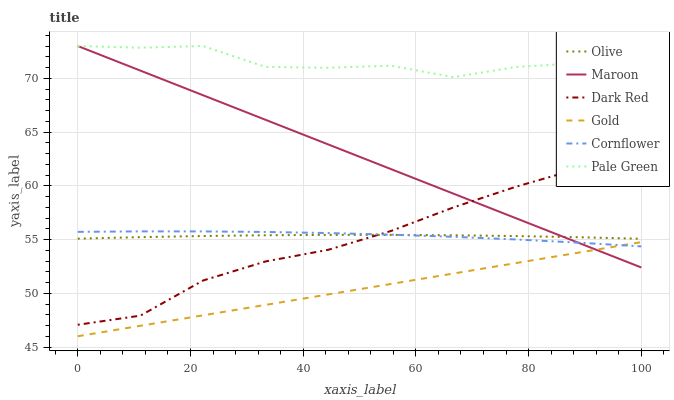Does Gold have the minimum area under the curve?
Answer yes or no. Yes. Does Pale Green have the maximum area under the curve?
Answer yes or no. Yes. Does Dark Red have the minimum area under the curve?
Answer yes or no. No. Does Dark Red have the maximum area under the curve?
Answer yes or no. No. Is Gold the smoothest?
Answer yes or no. Yes. Is Pale Green the roughest?
Answer yes or no. Yes. Is Dark Red the smoothest?
Answer yes or no. No. Is Dark Red the roughest?
Answer yes or no. No. Does Gold have the lowest value?
Answer yes or no. Yes. Does Dark Red have the lowest value?
Answer yes or no. No. Does Pale Green have the highest value?
Answer yes or no. Yes. Does Dark Red have the highest value?
Answer yes or no. No. Is Cornflower less than Pale Green?
Answer yes or no. Yes. Is Pale Green greater than Dark Red?
Answer yes or no. Yes. Does Maroon intersect Pale Green?
Answer yes or no. Yes. Is Maroon less than Pale Green?
Answer yes or no. No. Is Maroon greater than Pale Green?
Answer yes or no. No. Does Cornflower intersect Pale Green?
Answer yes or no. No. 